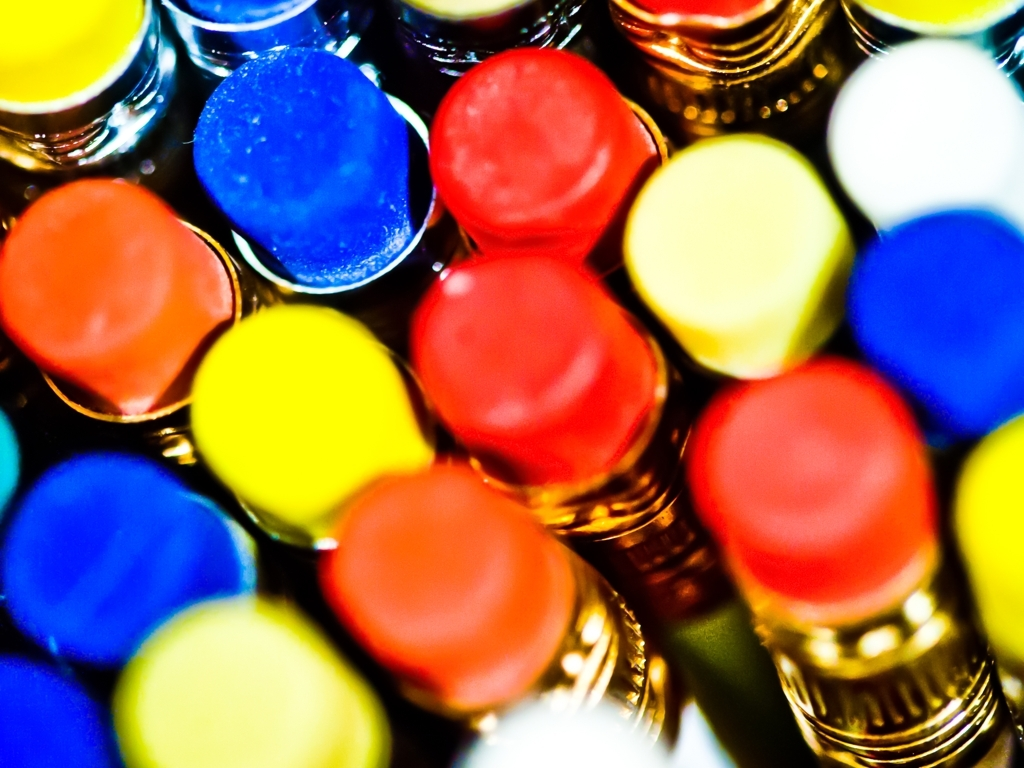What can you tell me about the colors in this image? The image displays a vibrant array of colors, with stark primary hues such as blue, red, and yellow prominently featured. These colors could signify a range of elements or subjects, from art supplies like crayons or markers to colorful buttons or capsules. The arrangement and brightness of the colors suggest a lively and energetic scene. 